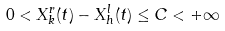<formula> <loc_0><loc_0><loc_500><loc_500>0 < X _ { k } ^ { r } ( t ) - X _ { h } ^ { l } ( t ) \leq C < + \infty</formula> 